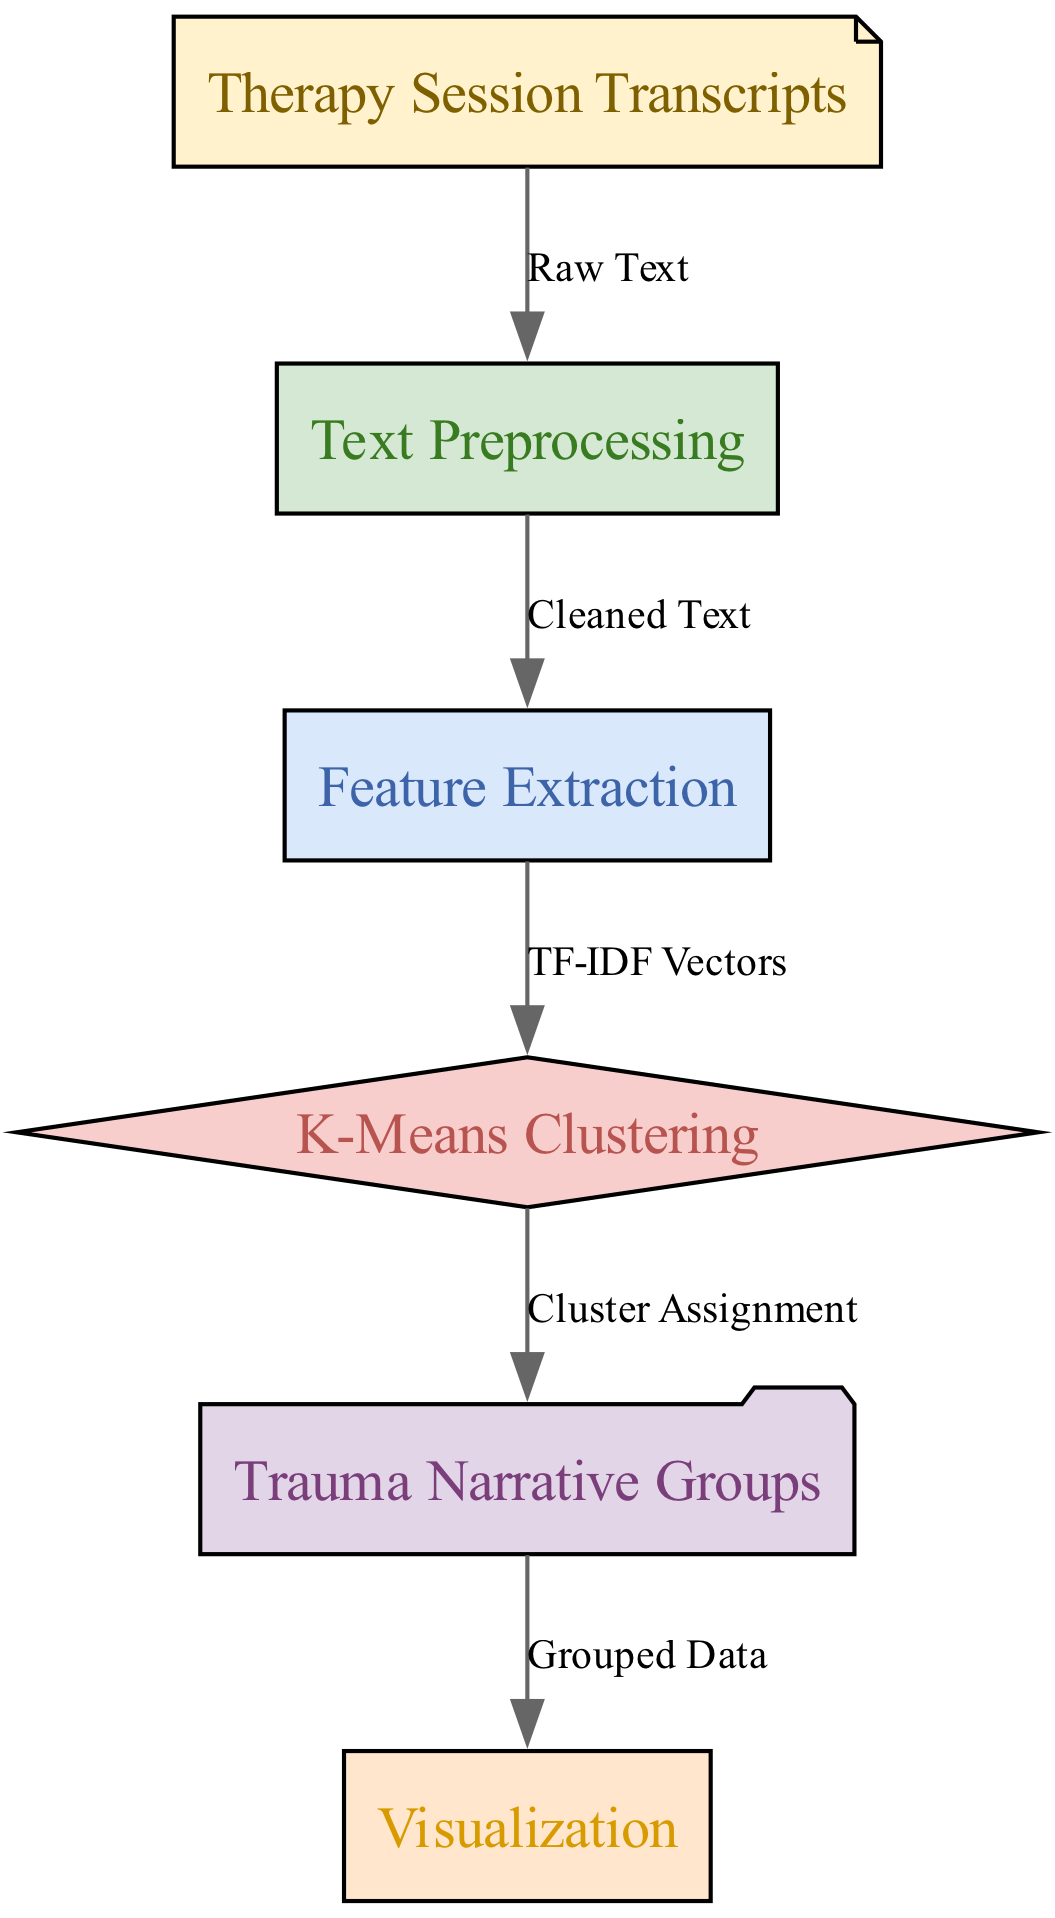What is the first step in the clustering process? The diagram begins with "Therapy Session Transcripts," indicating that this is the initial input that starts the process.
Answer: Therapy Session Transcripts What are the different types of nodes in the diagram? The diagram displays six nodes, which are "Therapy Session Transcripts," "Text Preprocessing," "Feature Extraction," "K-Means Clustering," "Trauma Narrative Groups," and "Visualization."
Answer: Six How many edges connect the nodes in this diagram? By counting the arrows connecting the nodes, there are five edges shown, indicating relationships between each step in the process.
Answer: Five What type of relationship exists between "Text Preprocessing" and "Feature Extraction"? The edge connecting these two nodes is labeled "Cleaned Text," representing that the result of preprocessing is necessary for feature extraction.
Answer: Cleaned Text Which node represents the final output of the clustering process? The last node in the flow is "Visualization," indicating that this node represents the final output resulting from the earlier steps in the diagram.
Answer: Visualization How does "Feature Extraction" relate to "K-Means Clustering"? The diagram shows a link from "Feature Extraction" to "K-Means Clustering" marked with "TF-IDF Vectors," illustrating that this is the input for the clustering algorithm.
Answer: TF-IDF Vectors What is the output from "K-Means Clustering"? The output from this node is connected to "Trauma Narrative Groups," indicating that the clustering process results in the assignment of narratives into groups.
Answer: Cluster Assignment What is the significance of "Trauma Narrative Groups" in the context of the diagram? This node signifies the resulting clusters formed from the data processed through the preceding steps, specifically focusing on trauma narratives.
Answer: Trauma Narrative Groups What does the node "Text Preprocessing" clean? The node "Text Preprocessing" is essential for cleaning the data before it can be analyzed further; it cleans the raw transcripts from therapy sessions.
Answer: Raw Text 